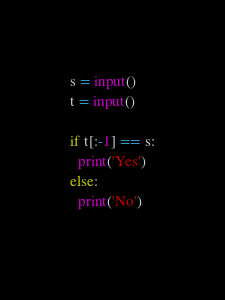Convert code to text. <code><loc_0><loc_0><loc_500><loc_500><_Python_>s = input()
t = input()

if t[:-1] == s:
  print('Yes')
else:
  print('No')
  
</code> 